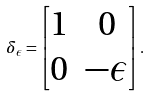Convert formula to latex. <formula><loc_0><loc_0><loc_500><loc_500>\delta _ { \epsilon } = \begin{bmatrix} 1 & 0 \\ 0 & - \epsilon \\ \end{bmatrix} .</formula> 